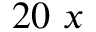<formula> <loc_0><loc_0><loc_500><loc_500>2 0 x</formula> 